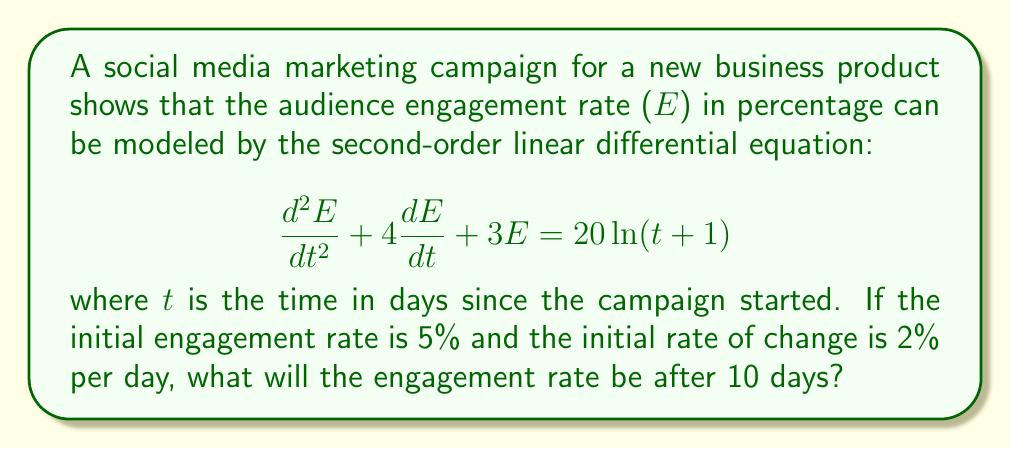Can you answer this question? To solve this problem, we need to follow these steps:

1) First, we need to find the general solution of the homogeneous equation:
   $$\frac{d^2E}{dt^2} + 4\frac{dE}{dt} + 3E = 0$$

   The characteristic equation is $r^2 + 4r + 3 = 0$
   Solving this, we get $r = -1$ or $r = -3$
   So, the homogeneous solution is:
   $$E_h = c_1e^{-t} + c_2e^{-3t}$$

2) Next, we need to find a particular solution. Let's assume it has the form:
   $$E_p = A\ln(t+1) + B$$

   Substituting this into the original equation:
   $$0 + 0 + 3(A\ln(t+1) + B) = 20\ln(t+1)$$

   Equating coefficients:
   $$3A = 20, \quad 3B = 0$$
   $$A = \frac{20}{3}, \quad B = 0$$

   So, the particular solution is:
   $$E_p = \frac{20}{3}\ln(t+1)$$

3) The general solution is the sum of the homogeneous and particular solutions:
   $$E = c_1e^{-t} + c_2e^{-3t} + \frac{20}{3}\ln(t+1)$$

4) Now we use the initial conditions to find $c_1$ and $c_2$:
   At $t = 0$: $E(0) = 5$ and $E'(0) = 2$

   $$5 = c_1 + c_2 + 0$$
   $$2 = -c_1 - 3c_2 + \frac{20}{3}$$

   Solving these equations:
   $$c_1 = \frac{19}{2}, \quad c_2 = -\frac{9}{2}$$

5) Therefore, the complete solution is:
   $$E = \frac{19}{2}e^{-t} - \frac{9}{2}e^{-3t} + \frac{20}{3}\ln(t+1)$$

6) To find the engagement rate after 10 days, we substitute $t = 10$:
   $$E(10) = \frac{19}{2}e^{-10} - \frac{9}{2}e^{-30} + \frac{20}{3}\ln(11)$$

7) Calculating this (you may use a calculator):
   $$E(10) \approx 15.94$$
Answer: The engagement rate after 10 days will be approximately 15.94%. 